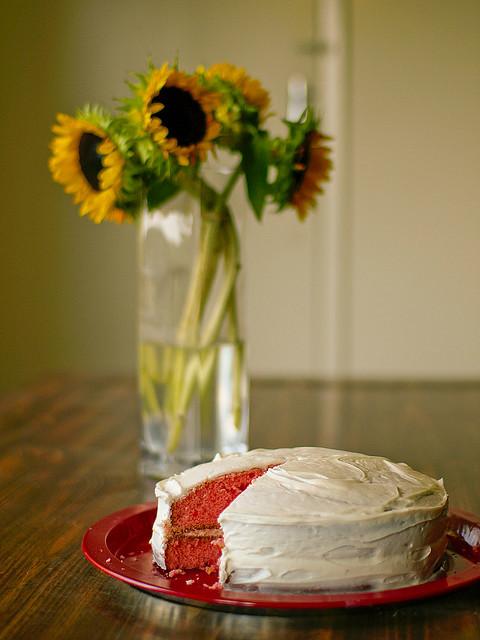What kind of frosting does the cake have?
Be succinct. Vanilla. Is this a professionally made cake?
Answer briefly. No. What type of flower is in the background?
Be succinct. Sunflower. What flavor is the frosting?
Be succinct. Vanilla. Would this be more appropriate for a boy or girl baby shower?
Write a very short answer. Girl. What color is in the vase?
Give a very brief answer. Clear. At what point in dinner might this be served?
Keep it brief. Dessert. What species of flowers are those?
Keep it brief. Sunflowers. 